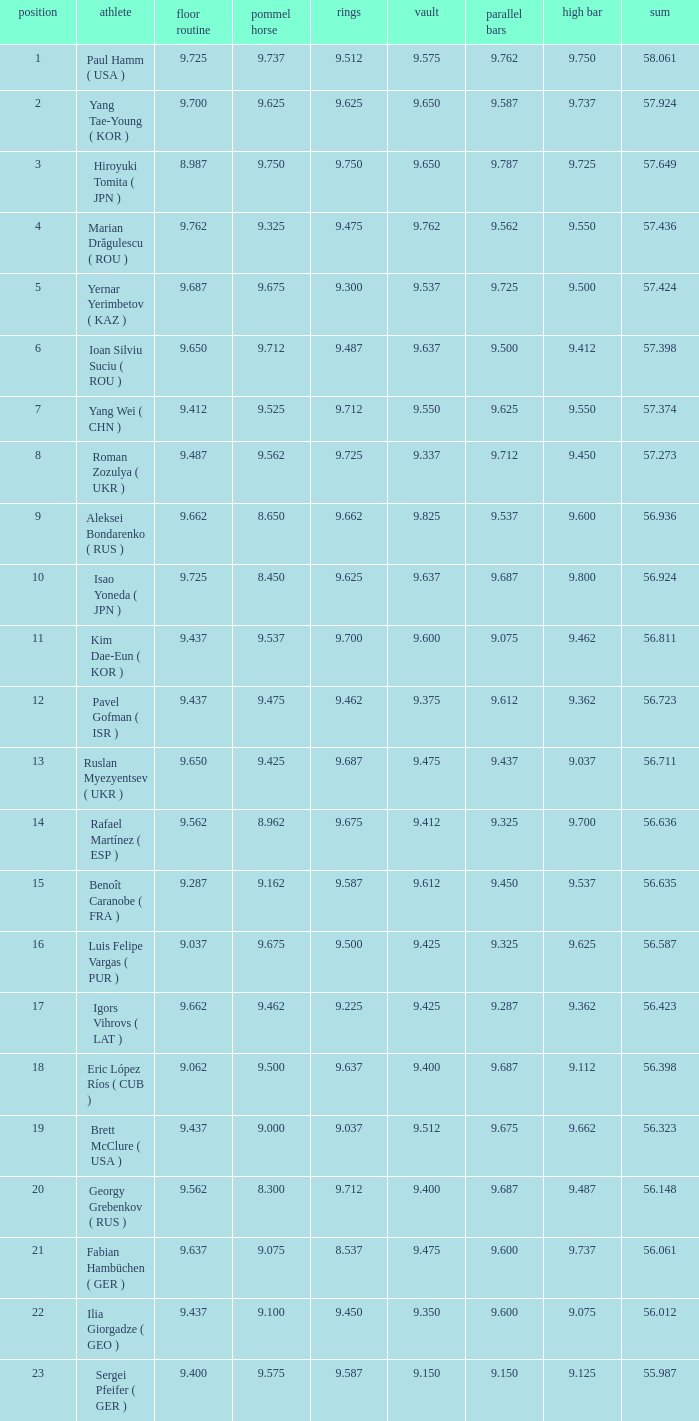What is the total score when the score for floor exercise was 9.287? 56.635. 